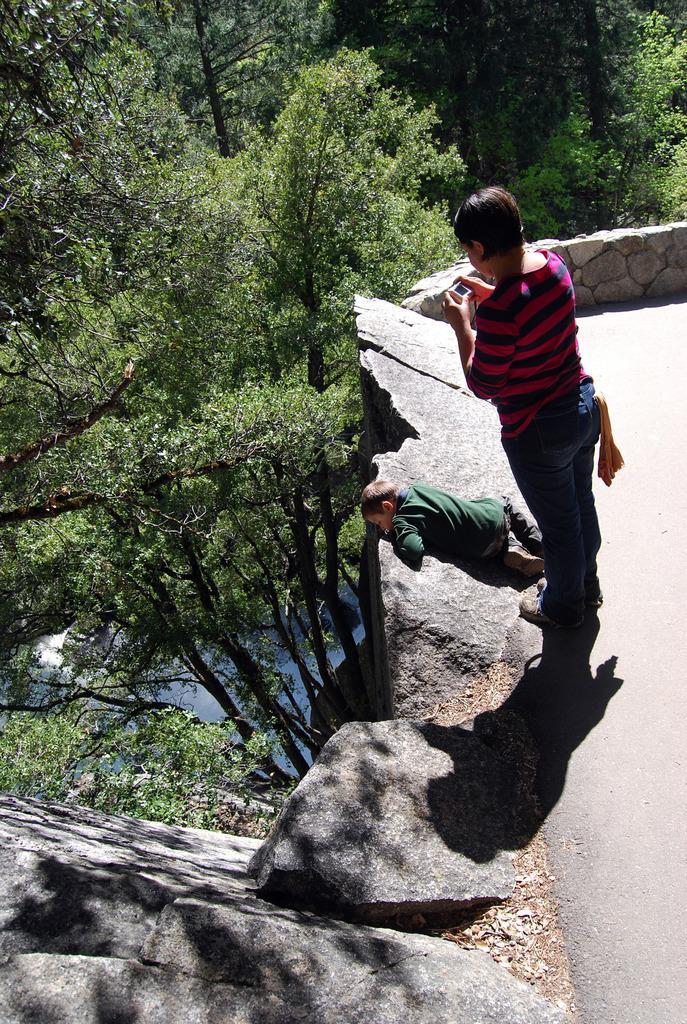In one or two sentences, can you explain what this image depicts? In this image I can see a person standing and holding an object. And there is a child lying on the rock. Also there are trees and rocks,. 